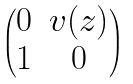Convert formula to latex. <formula><loc_0><loc_0><loc_500><loc_500>\begin{pmatrix} 0 & v ( z ) \\ 1 & 0 \end{pmatrix}</formula> 